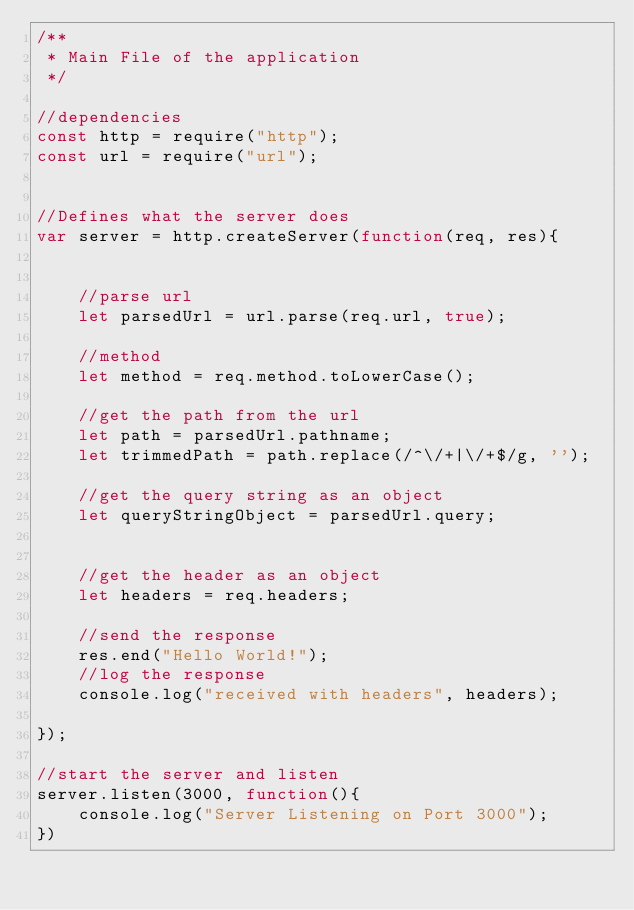Convert code to text. <code><loc_0><loc_0><loc_500><loc_500><_JavaScript_>/**
 * Main File of the application
 */

//dependencies
const http = require("http");
const url = require("url");


//Defines what the server does
var server = http.createServer(function(req, res){
  

    //parse url
    let parsedUrl = url.parse(req.url, true);

    //method
    let method = req.method.toLowerCase();

    //get the path from the url
    let path = parsedUrl.pathname;
    let trimmedPath = path.replace(/^\/+|\/+$/g, '');

    //get the query string as an object
    let queryStringObject = parsedUrl.query;


    //get the header as an object
    let headers = req.headers;

    //send the response
    res.end("Hello World!");
    //log the response
    console.log("received with headers", headers);

});

//start the server and listen
server.listen(3000, function(){
    console.log("Server Listening on Port 3000");
})</code> 